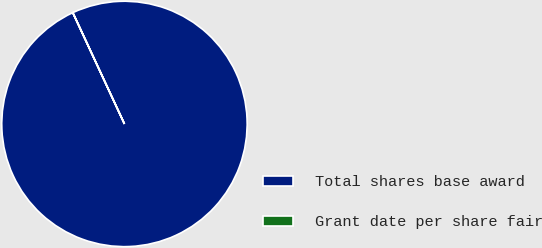<chart> <loc_0><loc_0><loc_500><loc_500><pie_chart><fcel>Total shares base award<fcel>Grant date per share fair<nl><fcel>99.99%<fcel>0.01%<nl></chart> 